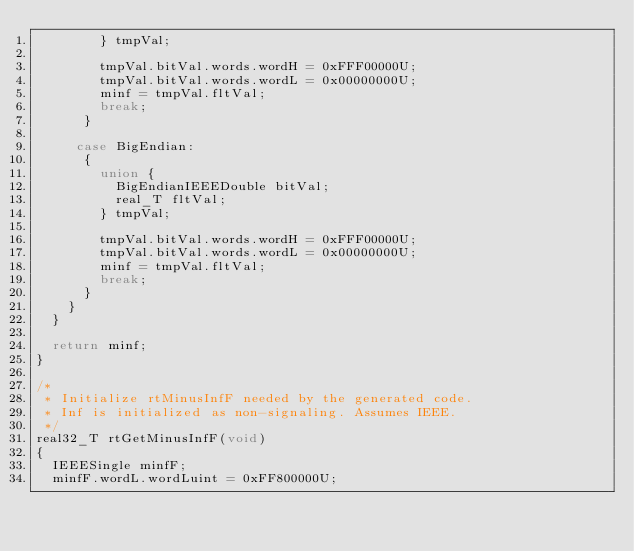<code> <loc_0><loc_0><loc_500><loc_500><_C_>        } tmpVal;

        tmpVal.bitVal.words.wordH = 0xFFF00000U;
        tmpVal.bitVal.words.wordL = 0x00000000U;
        minf = tmpVal.fltVal;
        break;
      }

     case BigEndian:
      {
        union {
          BigEndianIEEEDouble bitVal;
          real_T fltVal;
        } tmpVal;

        tmpVal.bitVal.words.wordH = 0xFFF00000U;
        tmpVal.bitVal.words.wordL = 0x00000000U;
        minf = tmpVal.fltVal;
        break;
      }
    }
  }

  return minf;
}

/*
 * Initialize rtMinusInfF needed by the generated code.
 * Inf is initialized as non-signaling. Assumes IEEE.
 */
real32_T rtGetMinusInfF(void)
{
  IEEESingle minfF;
  minfF.wordL.wordLuint = 0xFF800000U;</code> 